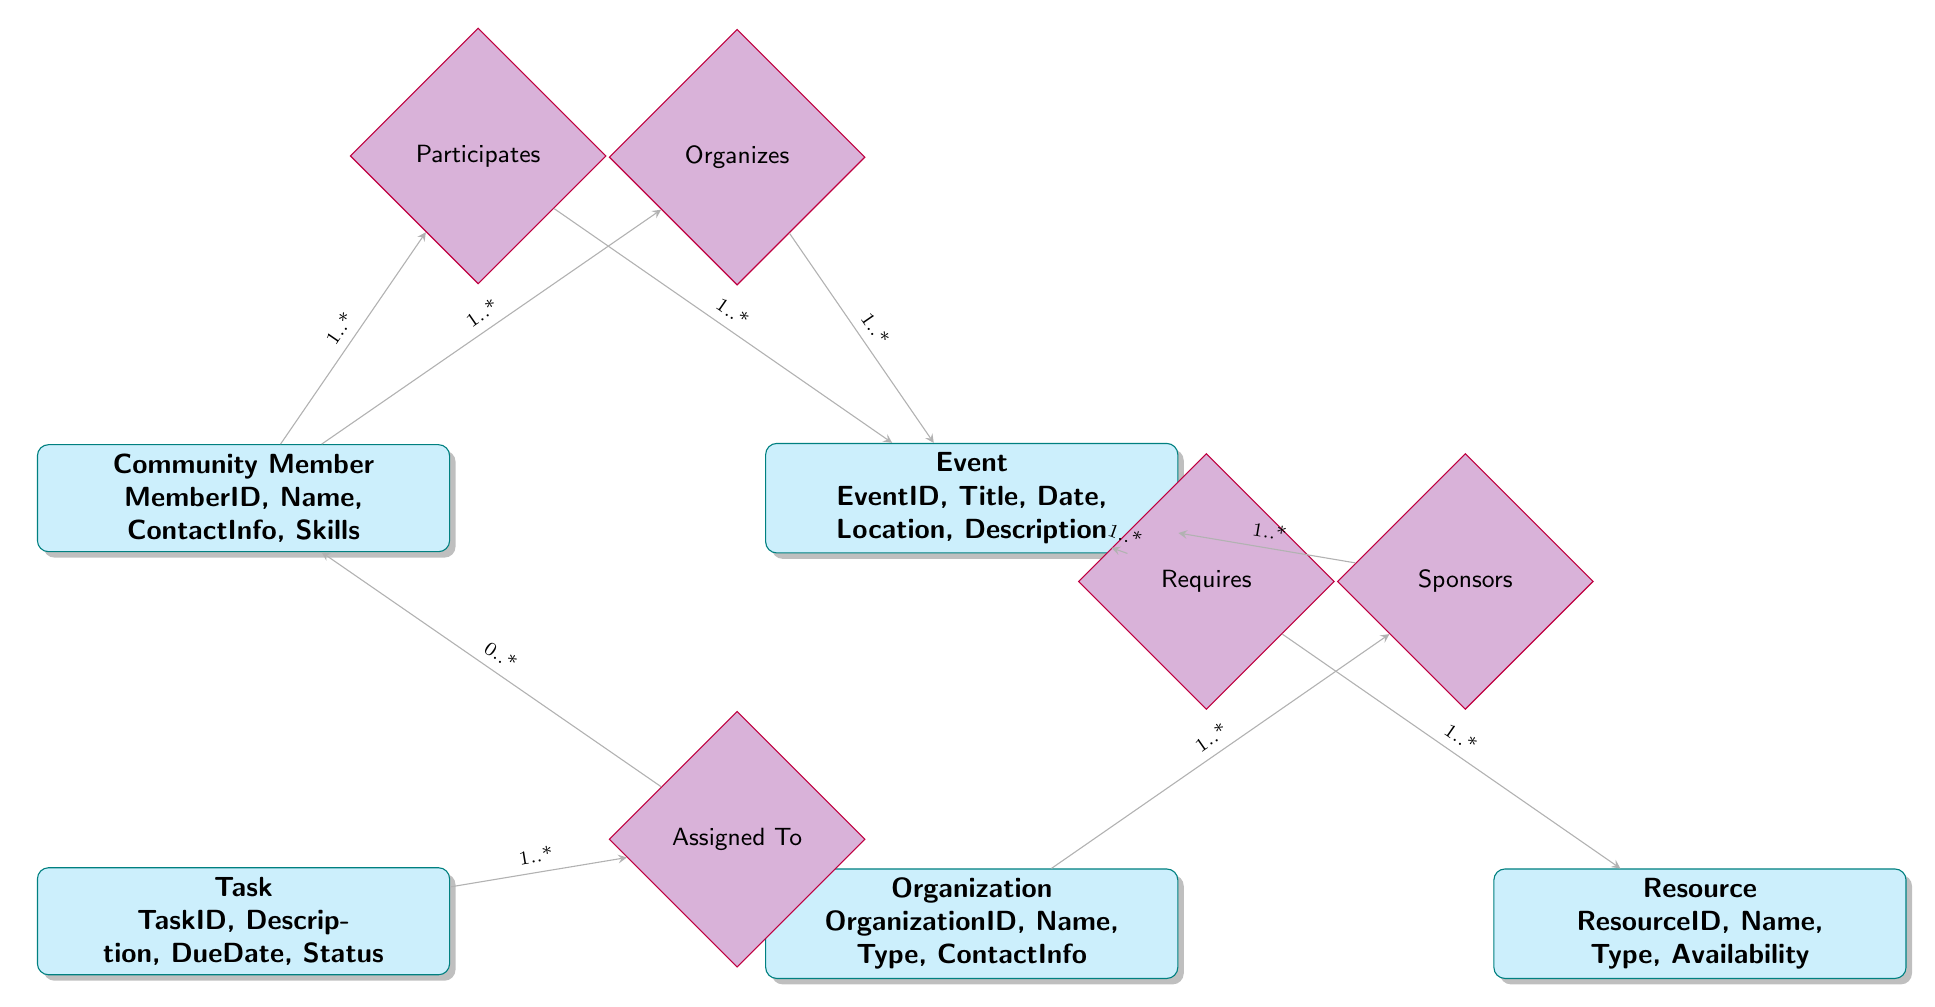What entities are involved in event planning? The diagram shows five entities: Community Member, Event, Organization, Task, and Resource.
Answer: Community Member, Event, Organization, Task, Resource What is the cardinality of the relationship between Community Members and Events in "Organizes"? The cardinality indicates that one Community Member can organize multiple Events, and one Event can be organized by multiple Community Members, represented as "1..*".
Answer: 1..* How many types of relationships are present in this diagram? There are five relationships depicted: Organizes, Participates, Sponsors, Assigned To, and Requires.
Answer: 5 Which entity provides resources for an Event? The "Requires" relationship connects Event and Resource entities, indicating that Events need Resources.
Answer: Resource How is a Task associated with Community Members? A Task can be assigned to zero or multiple Community Members, while one Community Member can be assigned to multiple Tasks. This is described by the "Assigned To" relationship with cardinality "0..*".
Answer: Task Which entity contributes financially to Events? The "Sponsors" relationship indicates that Organizations sponsor Events with contributions.
Answer: Organization What is the main purpose of the "Participates" relationship? The "Participates" relationship allows multiple Community Members to participate in multiple Events, indicating local engagement.
Answer: Local Engagement Are Resources required by Events? Yes, the "Requires" relationship confirms that Events need Resources to be successfully executed.
Answer: Yes Which entity has a variety of skills? The Community Member entity has the attribute "Skills," indicating its diversity.
Answer: Community Member What is the purpose of the Task entity in this diagram? The Task entity represents the specific activities needed for organizing Events, assigning roles to Community Members.
Answer: Organizing Events 